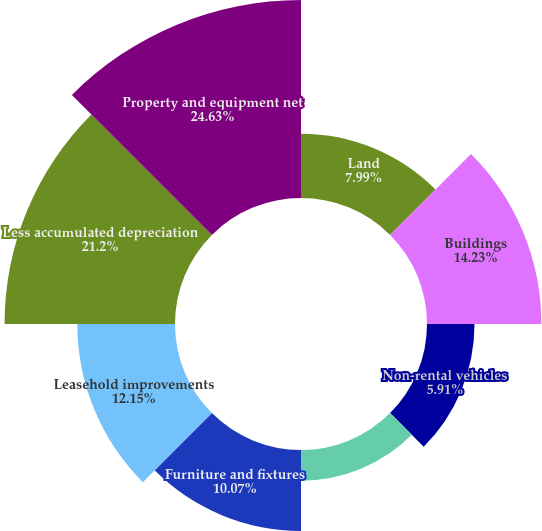<chart> <loc_0><loc_0><loc_500><loc_500><pie_chart><fcel>Land<fcel>Buildings<fcel>Non-rental vehicles<fcel>Machinery and equipment<fcel>Furniture and fixtures<fcel>Leasehold improvements<fcel>Less accumulated depreciation<fcel>Property and equipment net<nl><fcel>7.99%<fcel>14.23%<fcel>5.91%<fcel>3.82%<fcel>10.07%<fcel>12.15%<fcel>21.2%<fcel>24.63%<nl></chart> 